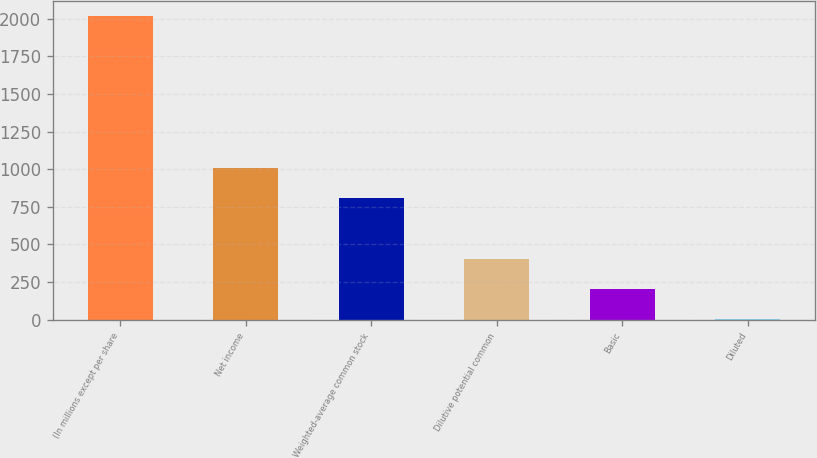<chart> <loc_0><loc_0><loc_500><loc_500><bar_chart><fcel>(In millions except per share<fcel>Net income<fcel>Weighted-average common stock<fcel>Dilutive potential common<fcel>Basic<fcel>Diluted<nl><fcel>2017<fcel>1010.03<fcel>808.64<fcel>405.86<fcel>204.47<fcel>3.08<nl></chart> 